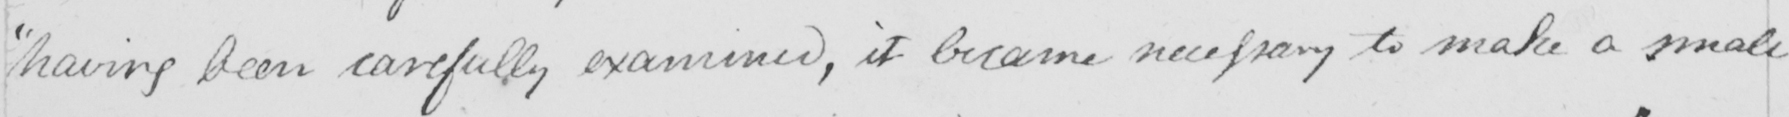Transcribe the text shown in this historical manuscript line. having been carefully examined , it became necessary to make a small 